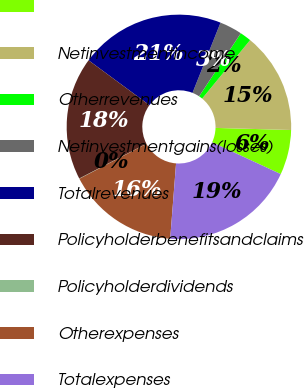Convert chart. <chart><loc_0><loc_0><loc_500><loc_500><pie_chart><ecel><fcel>Netinvestmentincome<fcel>Otherrevenues<fcel>Netinvestmentgains(losses)<fcel>Totalrevenues<fcel>Policyholderbenefitsandclaims<fcel>Policyholderdividends<fcel>Otherexpenses<fcel>Totalexpenses<nl><fcel>6.47%<fcel>14.51%<fcel>1.64%<fcel>3.25%<fcel>20.94%<fcel>17.72%<fcel>0.04%<fcel>16.11%<fcel>19.33%<nl></chart> 